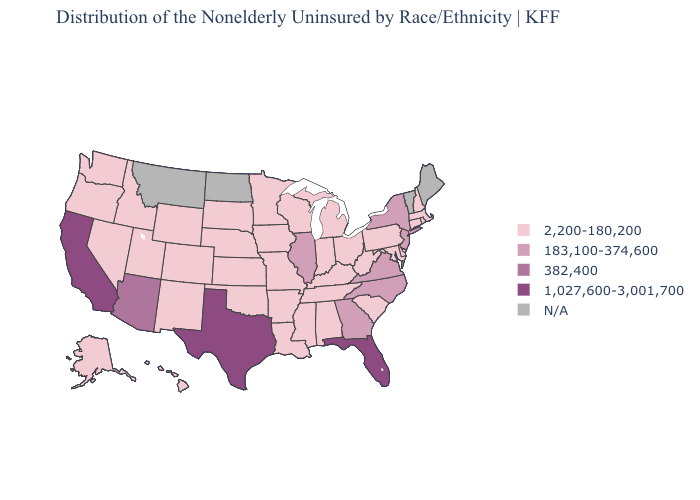What is the lowest value in the Northeast?
Keep it brief. 2,200-180,200. Name the states that have a value in the range 382,400?
Give a very brief answer. Arizona. Among the states that border Arkansas , which have the highest value?
Short answer required. Texas. Does Arizona have the lowest value in the West?
Quick response, please. No. What is the value of North Dakota?
Concise answer only. N/A. Which states hav the highest value in the MidWest?
Short answer required. Illinois. What is the value of Maine?
Answer briefly. N/A. Name the states that have a value in the range 1,027,600-3,001,700?
Concise answer only. California, Florida, Texas. What is the value of Indiana?
Keep it brief. 2,200-180,200. Does the map have missing data?
Write a very short answer. Yes. What is the value of Illinois?
Answer briefly. 183,100-374,600. What is the lowest value in the USA?
Keep it brief. 2,200-180,200. Name the states that have a value in the range 382,400?
Short answer required. Arizona. Does the map have missing data?
Keep it brief. Yes. 